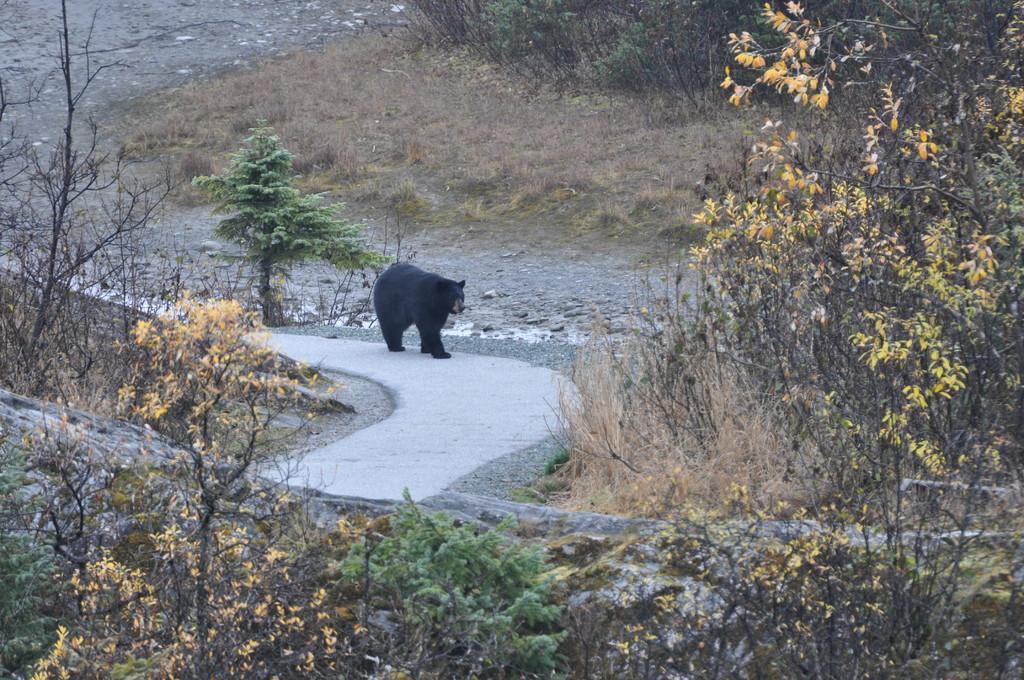Please provide a concise description of this image. In this image we can see a bear is walking on the road. Right side of the image trees are present. Background dry grass is there. 